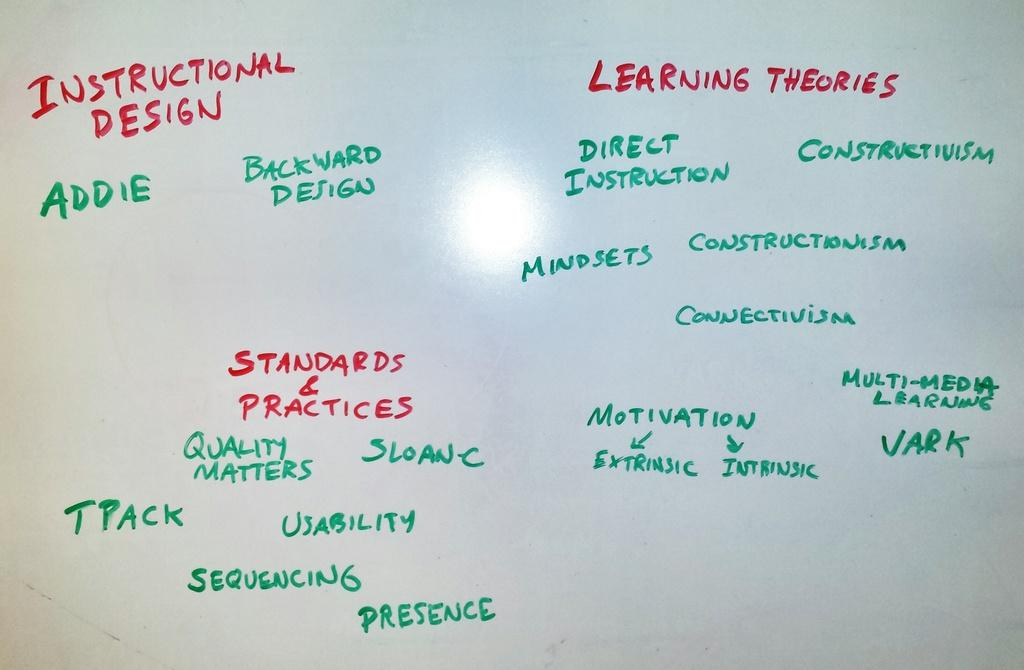<image>
Render a clear and concise summary of the photo. A white board has Learning Theories written on it in marker. 